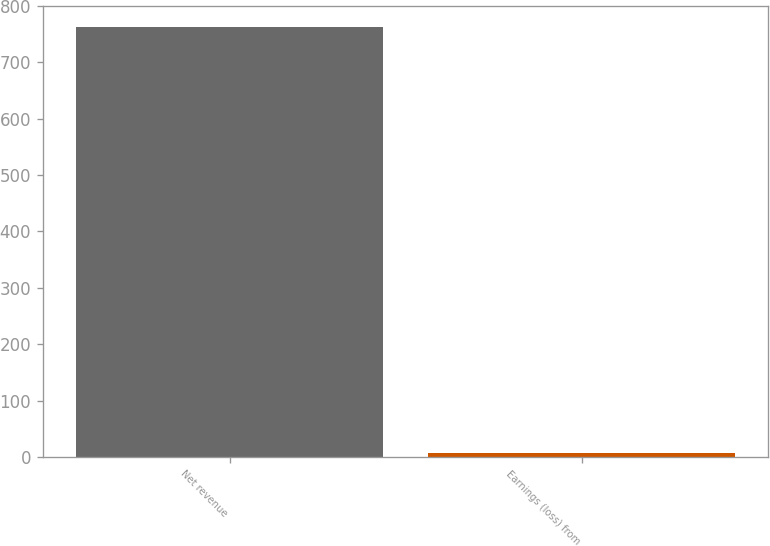Convert chart to OTSL. <chart><loc_0><loc_0><loc_500><loc_500><bar_chart><fcel>Net revenue<fcel>Earnings (loss) from<nl><fcel>762<fcel>7.5<nl></chart> 